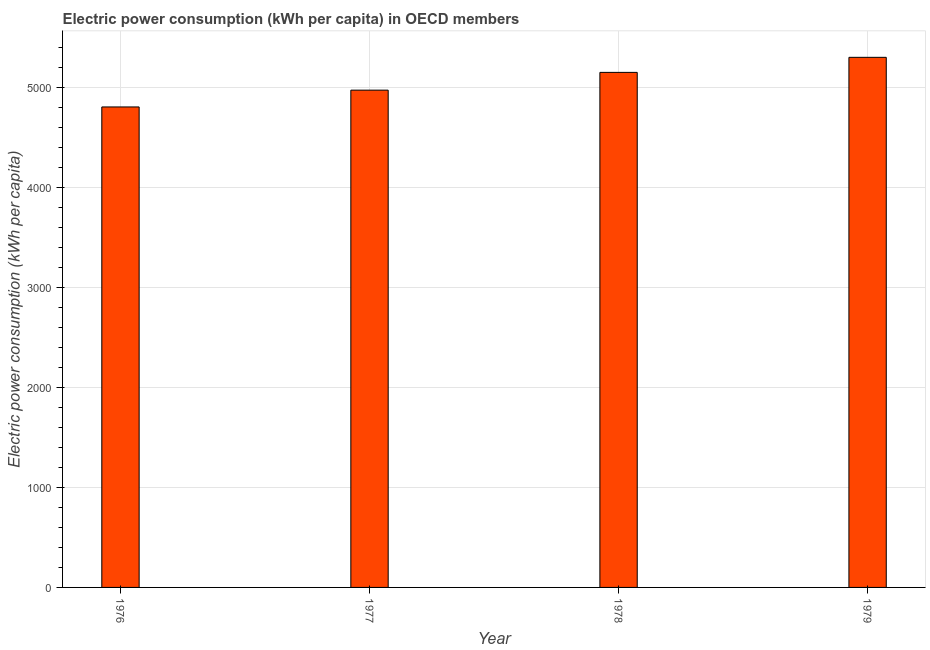Does the graph contain grids?
Offer a very short reply. Yes. What is the title of the graph?
Offer a very short reply. Electric power consumption (kWh per capita) in OECD members. What is the label or title of the Y-axis?
Offer a very short reply. Electric power consumption (kWh per capita). What is the electric power consumption in 1978?
Provide a short and direct response. 5153.86. Across all years, what is the maximum electric power consumption?
Your answer should be compact. 5304.44. Across all years, what is the minimum electric power consumption?
Your answer should be very brief. 4807.92. In which year was the electric power consumption maximum?
Ensure brevity in your answer.  1979. In which year was the electric power consumption minimum?
Keep it short and to the point. 1976. What is the sum of the electric power consumption?
Offer a very short reply. 2.02e+04. What is the difference between the electric power consumption in 1976 and 1977?
Keep it short and to the point. -168.14. What is the average electric power consumption per year?
Offer a terse response. 5060.57. What is the median electric power consumption?
Offer a very short reply. 5064.96. Do a majority of the years between 1976 and 1979 (inclusive) have electric power consumption greater than 1200 kWh per capita?
Give a very brief answer. Yes. What is the ratio of the electric power consumption in 1977 to that in 1978?
Offer a very short reply. 0.97. Is the electric power consumption in 1978 less than that in 1979?
Your response must be concise. Yes. What is the difference between the highest and the second highest electric power consumption?
Your response must be concise. 150.58. Is the sum of the electric power consumption in 1976 and 1979 greater than the maximum electric power consumption across all years?
Your response must be concise. Yes. What is the difference between the highest and the lowest electric power consumption?
Your answer should be compact. 496.53. How many bars are there?
Offer a terse response. 4. Are all the bars in the graph horizontal?
Give a very brief answer. No. What is the Electric power consumption (kWh per capita) in 1976?
Offer a very short reply. 4807.92. What is the Electric power consumption (kWh per capita) in 1977?
Give a very brief answer. 4976.06. What is the Electric power consumption (kWh per capita) in 1978?
Give a very brief answer. 5153.86. What is the Electric power consumption (kWh per capita) of 1979?
Give a very brief answer. 5304.44. What is the difference between the Electric power consumption (kWh per capita) in 1976 and 1977?
Make the answer very short. -168.14. What is the difference between the Electric power consumption (kWh per capita) in 1976 and 1978?
Offer a very short reply. -345.95. What is the difference between the Electric power consumption (kWh per capita) in 1976 and 1979?
Give a very brief answer. -496.53. What is the difference between the Electric power consumption (kWh per capita) in 1977 and 1978?
Your response must be concise. -177.81. What is the difference between the Electric power consumption (kWh per capita) in 1977 and 1979?
Ensure brevity in your answer.  -328.39. What is the difference between the Electric power consumption (kWh per capita) in 1978 and 1979?
Provide a short and direct response. -150.58. What is the ratio of the Electric power consumption (kWh per capita) in 1976 to that in 1977?
Offer a terse response. 0.97. What is the ratio of the Electric power consumption (kWh per capita) in 1976 to that in 1978?
Your answer should be very brief. 0.93. What is the ratio of the Electric power consumption (kWh per capita) in 1976 to that in 1979?
Your answer should be compact. 0.91. What is the ratio of the Electric power consumption (kWh per capita) in 1977 to that in 1978?
Provide a succinct answer. 0.97. What is the ratio of the Electric power consumption (kWh per capita) in 1977 to that in 1979?
Your response must be concise. 0.94. 